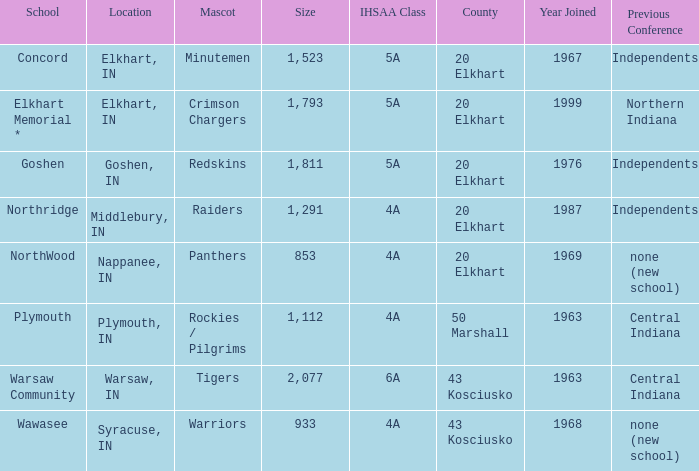What is the size of the team that was previously from Central Indiana conference, and is in IHSSA Class 4a? 1112.0. 